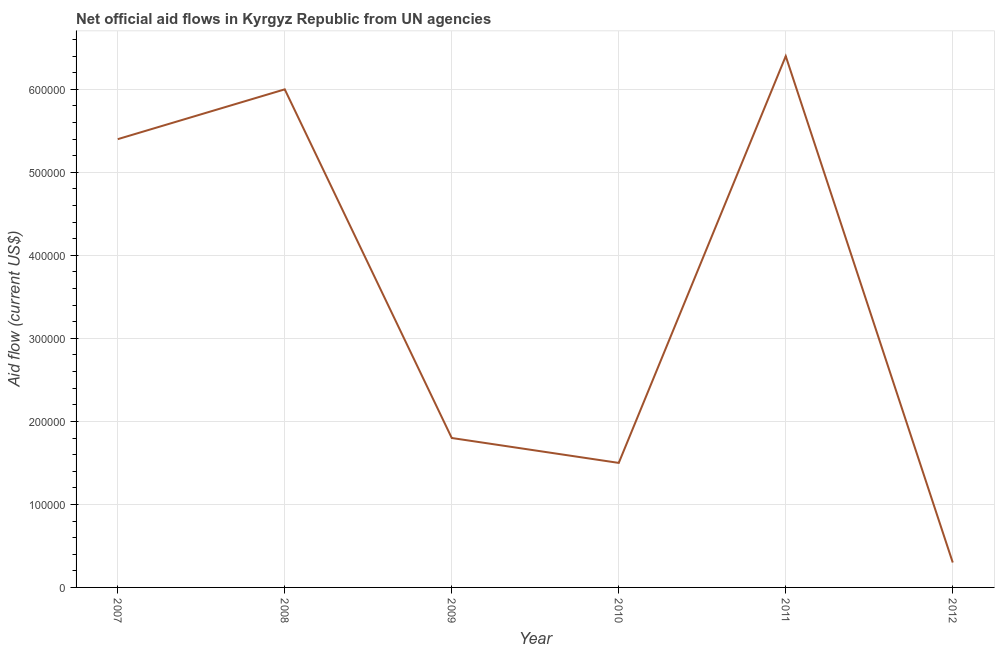What is the net official flows from un agencies in 2009?
Provide a short and direct response. 1.80e+05. Across all years, what is the maximum net official flows from un agencies?
Your answer should be very brief. 6.40e+05. Across all years, what is the minimum net official flows from un agencies?
Ensure brevity in your answer.  3.00e+04. What is the sum of the net official flows from un agencies?
Offer a terse response. 2.14e+06. What is the difference between the net official flows from un agencies in 2007 and 2008?
Make the answer very short. -6.00e+04. What is the average net official flows from un agencies per year?
Make the answer very short. 3.57e+05. What is the median net official flows from un agencies?
Your answer should be compact. 3.60e+05. In how many years, is the net official flows from un agencies greater than 180000 US$?
Keep it short and to the point. 3. Do a majority of the years between 2009 and 2011 (inclusive) have net official flows from un agencies greater than 200000 US$?
Give a very brief answer. No. What is the difference between the highest and the second highest net official flows from un agencies?
Keep it short and to the point. 4.00e+04. What is the difference between the highest and the lowest net official flows from un agencies?
Offer a very short reply. 6.10e+05. In how many years, is the net official flows from un agencies greater than the average net official flows from un agencies taken over all years?
Offer a terse response. 3. Does the net official flows from un agencies monotonically increase over the years?
Your answer should be very brief. No. How many years are there in the graph?
Offer a terse response. 6. What is the difference between two consecutive major ticks on the Y-axis?
Ensure brevity in your answer.  1.00e+05. Are the values on the major ticks of Y-axis written in scientific E-notation?
Your answer should be compact. No. What is the title of the graph?
Provide a short and direct response. Net official aid flows in Kyrgyz Republic from UN agencies. What is the label or title of the Y-axis?
Offer a terse response. Aid flow (current US$). What is the Aid flow (current US$) in 2007?
Your response must be concise. 5.40e+05. What is the Aid flow (current US$) in 2010?
Your response must be concise. 1.50e+05. What is the Aid flow (current US$) of 2011?
Give a very brief answer. 6.40e+05. What is the Aid flow (current US$) in 2012?
Your answer should be very brief. 3.00e+04. What is the difference between the Aid flow (current US$) in 2007 and 2008?
Offer a very short reply. -6.00e+04. What is the difference between the Aid flow (current US$) in 2007 and 2009?
Provide a short and direct response. 3.60e+05. What is the difference between the Aid flow (current US$) in 2007 and 2010?
Your answer should be compact. 3.90e+05. What is the difference between the Aid flow (current US$) in 2007 and 2012?
Your answer should be very brief. 5.10e+05. What is the difference between the Aid flow (current US$) in 2008 and 2011?
Offer a very short reply. -4.00e+04. What is the difference between the Aid flow (current US$) in 2008 and 2012?
Your answer should be compact. 5.70e+05. What is the difference between the Aid flow (current US$) in 2009 and 2010?
Give a very brief answer. 3.00e+04. What is the difference between the Aid flow (current US$) in 2009 and 2011?
Provide a succinct answer. -4.60e+05. What is the difference between the Aid flow (current US$) in 2009 and 2012?
Offer a terse response. 1.50e+05. What is the difference between the Aid flow (current US$) in 2010 and 2011?
Make the answer very short. -4.90e+05. What is the difference between the Aid flow (current US$) in 2010 and 2012?
Offer a very short reply. 1.20e+05. What is the difference between the Aid flow (current US$) in 2011 and 2012?
Keep it short and to the point. 6.10e+05. What is the ratio of the Aid flow (current US$) in 2007 to that in 2009?
Give a very brief answer. 3. What is the ratio of the Aid flow (current US$) in 2007 to that in 2010?
Provide a succinct answer. 3.6. What is the ratio of the Aid flow (current US$) in 2007 to that in 2011?
Your answer should be very brief. 0.84. What is the ratio of the Aid flow (current US$) in 2007 to that in 2012?
Offer a terse response. 18. What is the ratio of the Aid flow (current US$) in 2008 to that in 2009?
Make the answer very short. 3.33. What is the ratio of the Aid flow (current US$) in 2008 to that in 2011?
Provide a short and direct response. 0.94. What is the ratio of the Aid flow (current US$) in 2008 to that in 2012?
Give a very brief answer. 20. What is the ratio of the Aid flow (current US$) in 2009 to that in 2011?
Ensure brevity in your answer.  0.28. What is the ratio of the Aid flow (current US$) in 2009 to that in 2012?
Keep it short and to the point. 6. What is the ratio of the Aid flow (current US$) in 2010 to that in 2011?
Your answer should be compact. 0.23. What is the ratio of the Aid flow (current US$) in 2011 to that in 2012?
Make the answer very short. 21.33. 